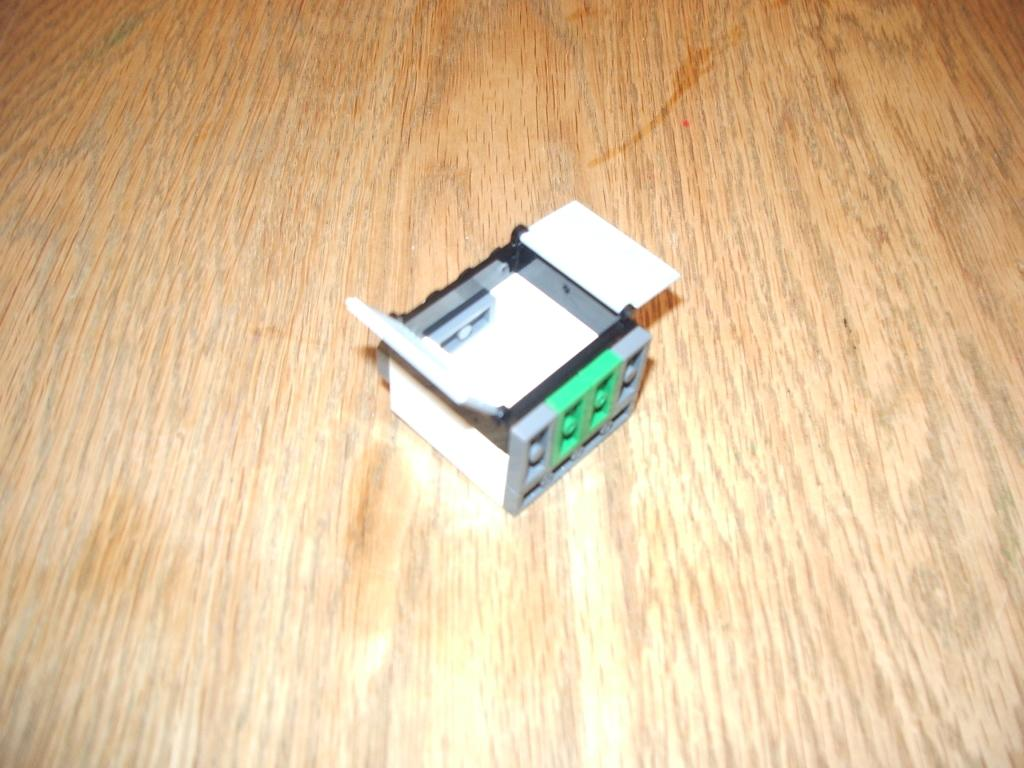What is the main object in the image? There is a block in the image. On what surface is the block placed? The block is placed on a wooden surface. What type of notebook is visible on the block in the image? There is no notebook present on the block in the image. What type of produce is visible on the block in the image? There is no produce present on the block in the image. 